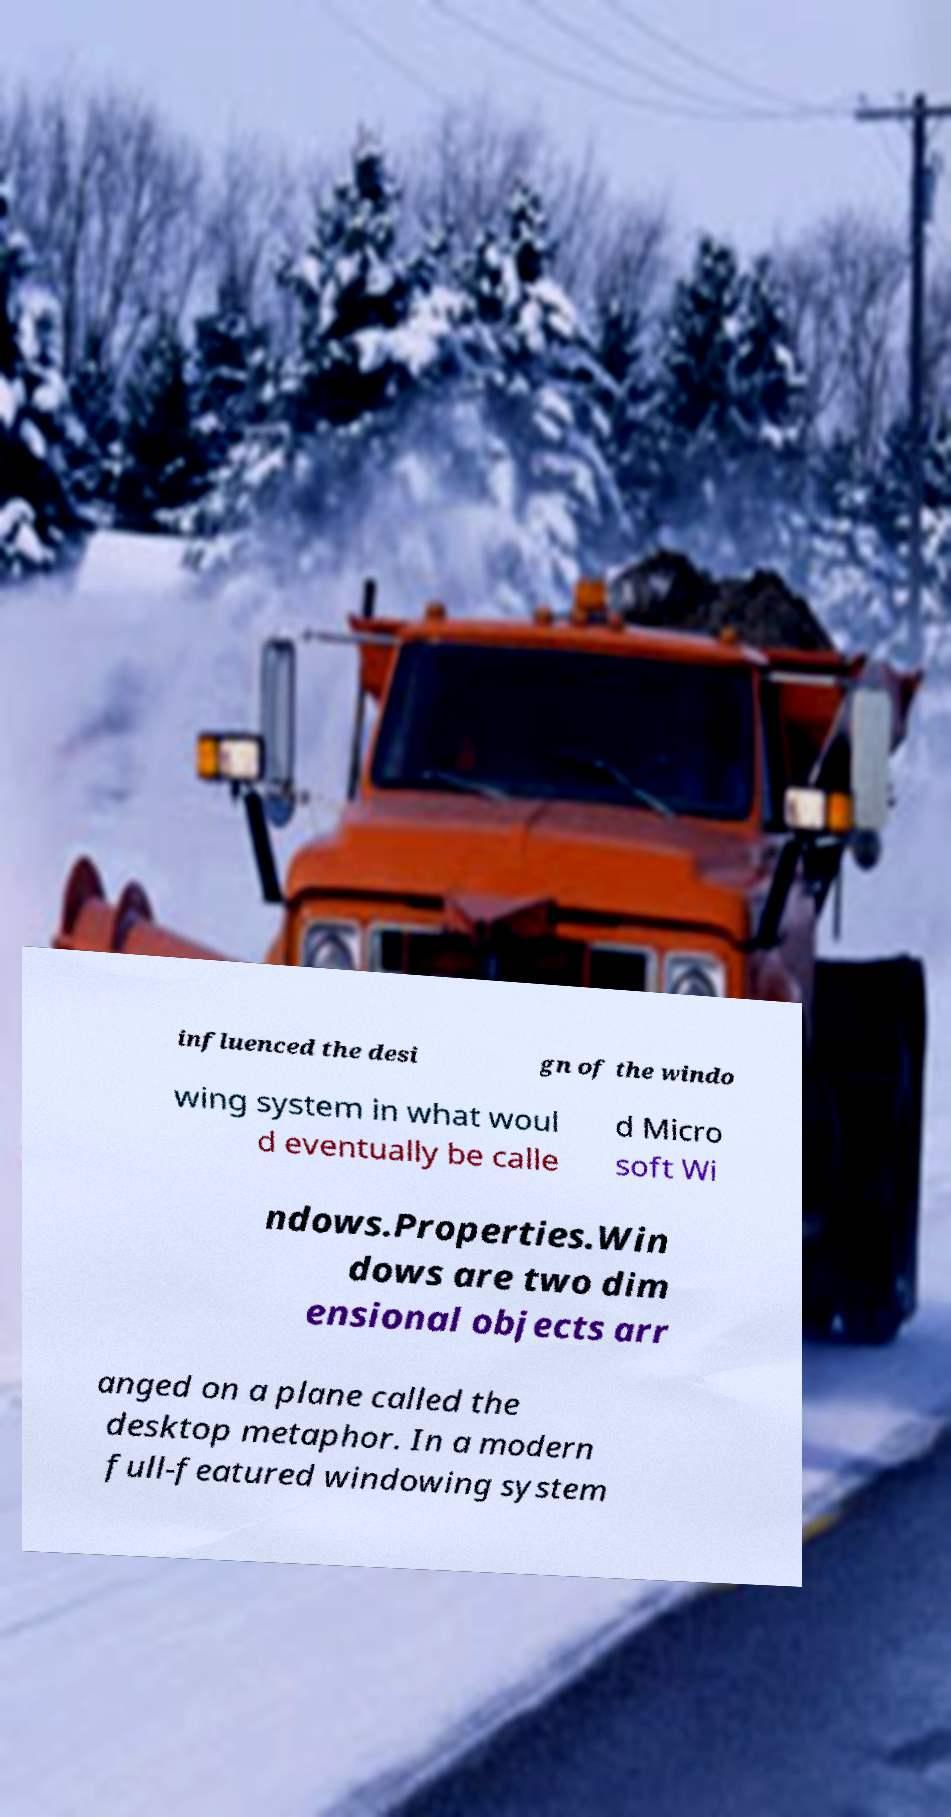Please read and relay the text visible in this image. What does it say? influenced the desi gn of the windo wing system in what woul d eventually be calle d Micro soft Wi ndows.Properties.Win dows are two dim ensional objects arr anged on a plane called the desktop metaphor. In a modern full-featured windowing system 